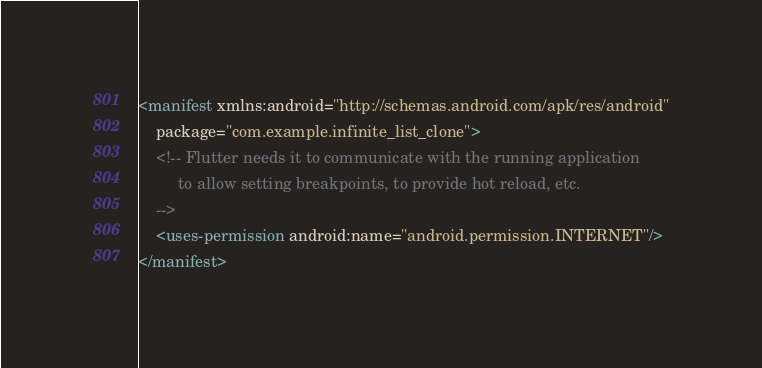<code> <loc_0><loc_0><loc_500><loc_500><_XML_><manifest xmlns:android="http://schemas.android.com/apk/res/android"
    package="com.example.infinite_list_clone">
    <!-- Flutter needs it to communicate with the running application
         to allow setting breakpoints, to provide hot reload, etc.
    -->
    <uses-permission android:name="android.permission.INTERNET"/>
</manifest>
</code> 